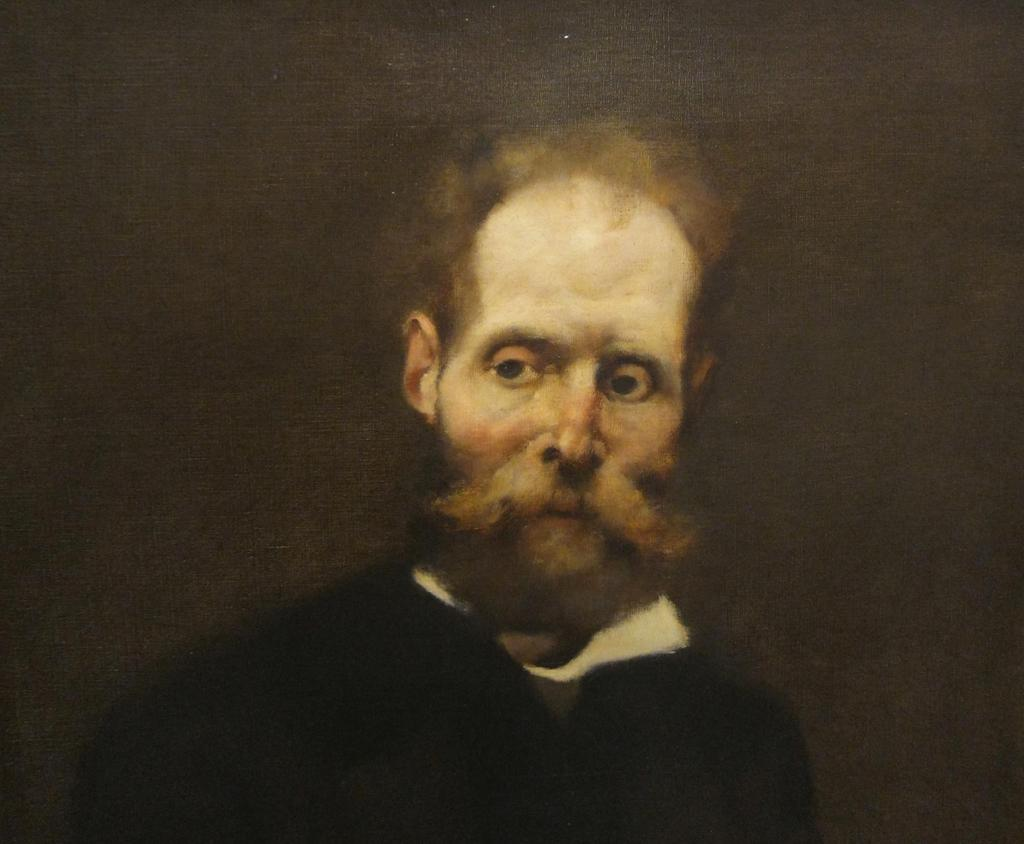Who or what is the main subject of the image? There is a person in the image. Can you describe the background of the image? The background of the image is dark. What time is depicted in the image? The time is not visible or indicated in the image. Is there a street visible in the image? No, there is no street visible in the image. 